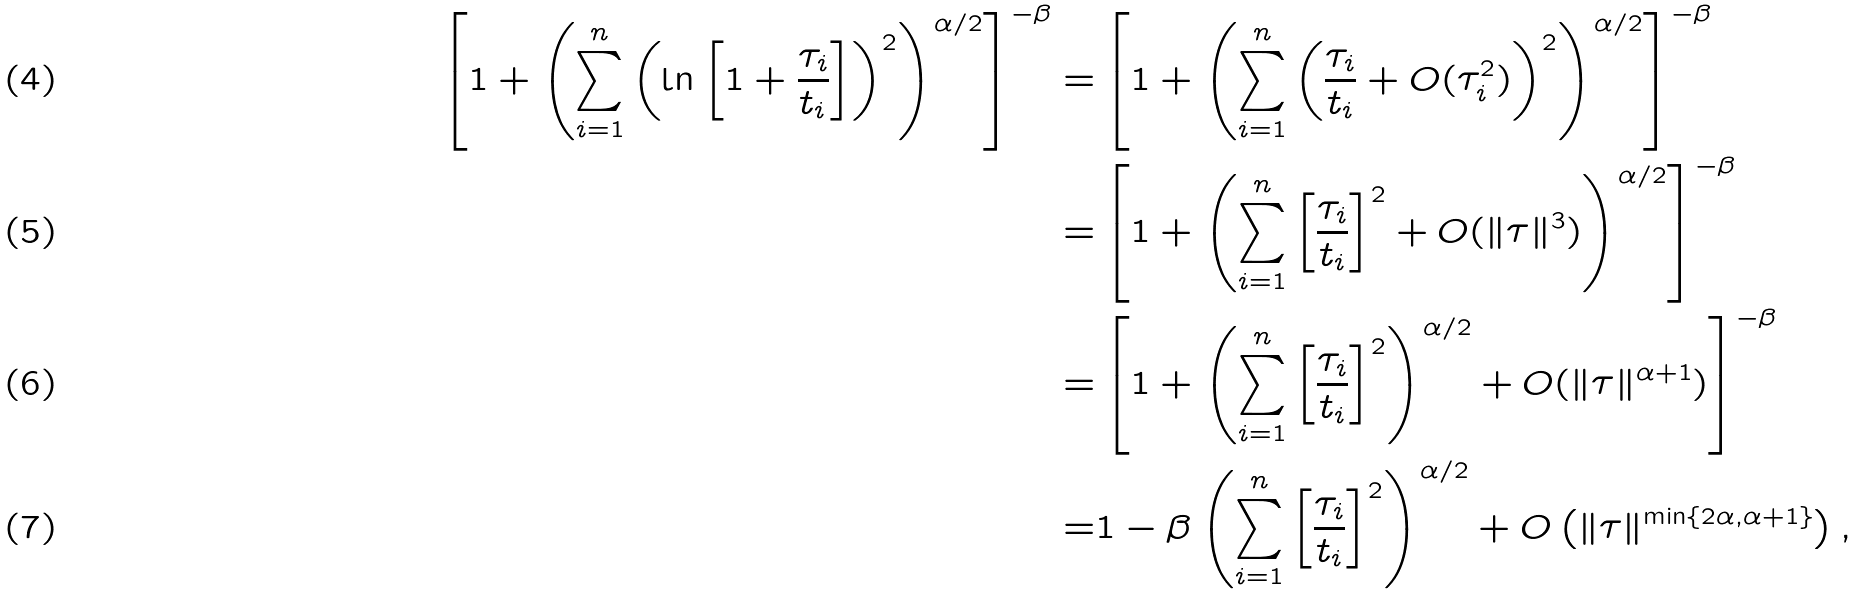<formula> <loc_0><loc_0><loc_500><loc_500>\left [ 1 + \left ( \sum _ { i = 1 } ^ { n } \left ( \ln \left [ 1 + \frac { \tau _ { i } } { t _ { i } } \right ] \right ) ^ { 2 } \right ) ^ { \alpha / 2 } \right ] ^ { - \beta } = & \left [ 1 + \left ( \sum _ { i = 1 } ^ { n } \left ( \frac { \tau _ { i } } { t _ { i } } + O ( \tau _ { i } ^ { 2 } ) \right ) ^ { 2 } \right ) ^ { \alpha / 2 } \right ] ^ { - \beta } \\ = & \left [ 1 + \left ( \sum _ { i = 1 } ^ { n } \left [ \frac { \tau _ { i } } { t _ { i } } \right ] ^ { 2 } + O ( \| \tau \| ^ { 3 } ) \right ) ^ { \alpha / 2 } \right ] ^ { - \beta } \\ = & \left [ 1 + \left ( \sum _ { i = 1 } ^ { n } \left [ \frac { \tau _ { i } } { t _ { i } } \right ] ^ { 2 } \right ) ^ { \alpha / 2 } + O ( \| \tau \| ^ { \alpha + 1 } ) \right ] ^ { - \beta } \\ = & 1 - \beta \left ( \sum _ { i = 1 } ^ { n } \left [ \frac { \tau _ { i } } { t _ { i } } \right ] ^ { 2 } \right ) ^ { \alpha / 2 } + O \left ( \| \tau \| ^ { \min \{ 2 \alpha , \alpha + 1 \} } \right ) ,</formula> 